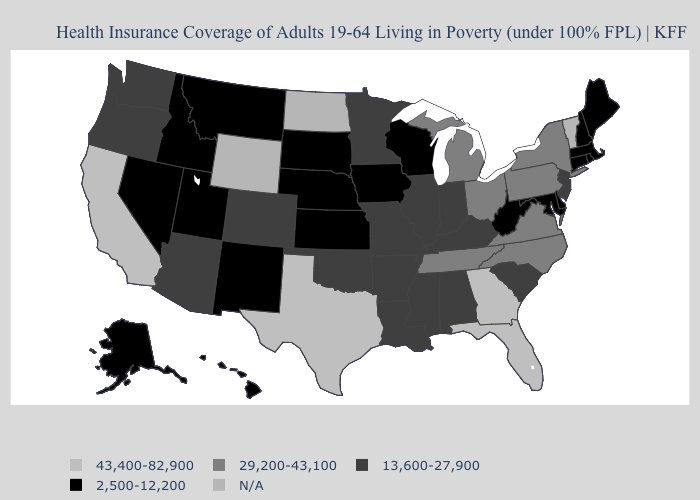What is the value of Alabama?
Keep it brief. 13,600-27,900. What is the lowest value in the USA?
Write a very short answer. 2,500-12,200. Which states have the lowest value in the Northeast?
Answer briefly. Connecticut, Maine, Massachusetts, New Hampshire, Rhode Island. Name the states that have a value in the range 2,500-12,200?
Give a very brief answer. Alaska, Connecticut, Delaware, Hawaii, Idaho, Iowa, Kansas, Maine, Maryland, Massachusetts, Montana, Nebraska, Nevada, New Hampshire, New Mexico, Rhode Island, South Dakota, Utah, West Virginia, Wisconsin. What is the value of South Carolina?
Be succinct. 13,600-27,900. What is the lowest value in the West?
Quick response, please. 2,500-12,200. What is the value of Wisconsin?
Give a very brief answer. 2,500-12,200. Name the states that have a value in the range N/A?
Quick response, please. North Dakota, Vermont, Wyoming. Is the legend a continuous bar?
Keep it brief. No. Name the states that have a value in the range 13,600-27,900?
Be succinct. Alabama, Arizona, Arkansas, Colorado, Illinois, Indiana, Kentucky, Louisiana, Minnesota, Mississippi, Missouri, New Jersey, Oklahoma, Oregon, South Carolina, Washington. Which states have the lowest value in the USA?
Keep it brief. Alaska, Connecticut, Delaware, Hawaii, Idaho, Iowa, Kansas, Maine, Maryland, Massachusetts, Montana, Nebraska, Nevada, New Hampshire, New Mexico, Rhode Island, South Dakota, Utah, West Virginia, Wisconsin. Is the legend a continuous bar?
Write a very short answer. No. Which states have the lowest value in the Northeast?
Give a very brief answer. Connecticut, Maine, Massachusetts, New Hampshire, Rhode Island. Name the states that have a value in the range 2,500-12,200?
Keep it brief. Alaska, Connecticut, Delaware, Hawaii, Idaho, Iowa, Kansas, Maine, Maryland, Massachusetts, Montana, Nebraska, Nevada, New Hampshire, New Mexico, Rhode Island, South Dakota, Utah, West Virginia, Wisconsin. 